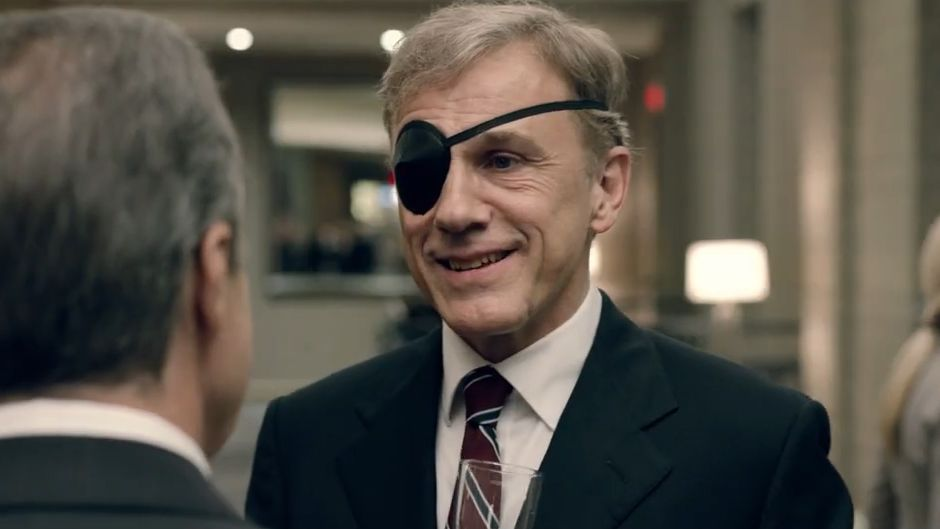If this were a setting in a science fiction novel, what futuristic elements could be added to enhance the scene? If this were a setting in a science fiction novel, several futuristic elements could be added to enhance the scene. The sleek lobby could be adorned with holographic displays showcasing cutting-edge technology, and autonomous drones flying overhead serving drinks. Christoph Waltz's character might be featuring a high-tech monocle with augmented reality capabilities, replacing the traditional eye patch. Conversations in the background could hint at interstellar travel and advanced AI collaborations. The lighting could be ambient and subtly responsive to the mood and emotions of the attendees, projecting a dynamic and interactive aura. Moreover, the dialogue could delve into topics such as the ethical implications of mind-uploading or the challenges of maintaining humanity in an era of post-biological existence. This would transform the scene into a vivid tapestry of speculative innovation, capturing the imagination of anyone immersed in the story. 